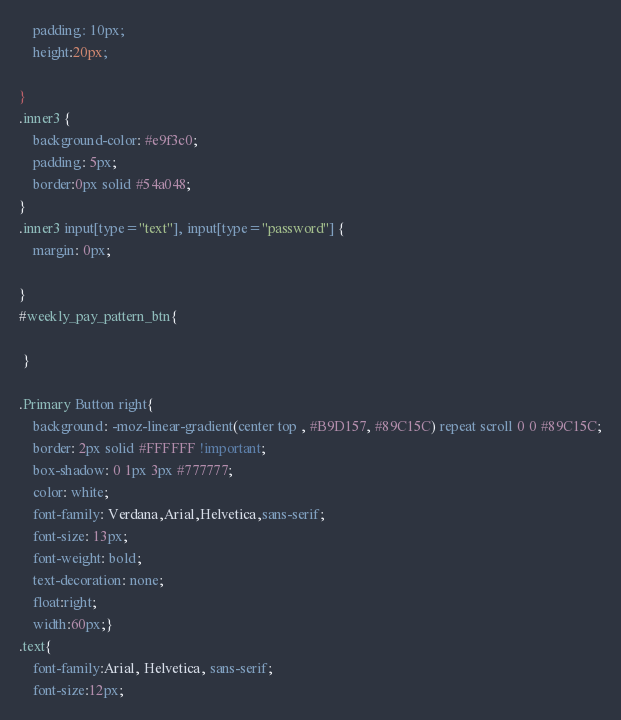Convert code to text. <code><loc_0><loc_0><loc_500><loc_500><_CSS_>    padding: 10px;
	height:20px;
 
}
.inner3 {
    background-color: #e9f3c0;
    padding: 5px;
	border:0px solid #54a048;
}
.inner3 input[type="text"], input[type="password"] {
	margin: 0px;
   
}
#weekly_pay_pattern_btn{
	 
 }
	
.Primary Button right{
 	background: -moz-linear-gradient(center top , #B9D157, #89C15C) repeat scroll 0 0 #89C15C;
    border: 2px solid #FFFFFF !important;
    box-shadow: 0 1px 3px #777777;
    color: white;
    font-family: Verdana,Arial,Helvetica,sans-serif;
    font-size: 13px;
    font-weight: bold;
    text-decoration: none;
	float:right;
	width:60px;}
.text{
	font-family:Arial, Helvetica, sans-serif;
	font-size:12px;</code> 